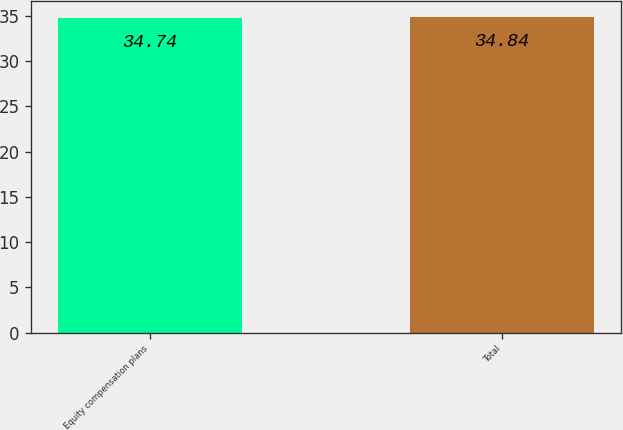Convert chart. <chart><loc_0><loc_0><loc_500><loc_500><bar_chart><fcel>Equity compensation plans<fcel>Total<nl><fcel>34.74<fcel>34.84<nl></chart> 